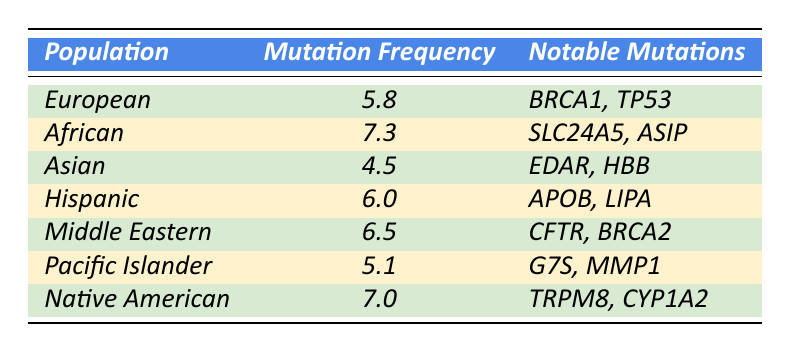What is the mutation frequency for the African population? The table shows that the mutation frequency for the African population is listed directly under the "Mutation Frequency" column as 7.3.
Answer: 7.3 Which population has the lowest mutation frequency? In the table, by comparing the "Mutation Frequency" values, the Asian population has the lowest mutation frequency at 4.5.
Answer: Asian What are the notable mutations for the Hispanic population? The table under the "Notable Mutations" column lists "APOB, LIPA" for the Hispanic population, which can be directly retrieved from the table.
Answer: APOB, LIPA How many populations have a mutation frequency greater than 6.0? By examining the table, the populations with mutation frequencies greater than 6.0 are African (7.3), Hispanic (6.0), Middle Eastern (6.5), and Native American (7.0). Thus, there are four populations.
Answer: 4 What is the average mutation frequency across all listed populations? To find the average, add the mutation frequencies: (5.8 + 7.3 + 4.5 + 6.0 + 6.5 + 5.1 + 7.0) = 42.2. There are 7 populations, so the average is 42.2 / 7 = 6.03.
Answer: 6.03 Is the mutation frequency for the Pacific Islander population higher than 6.0? The table shows that the mutation frequency for Pacific Islanders is 5.1, which is less than 6.0, thus the statement is false.
Answer: No Which population has the highest mutation frequency, and what is that frequency? From the table, the African population has the highest mutation frequency at 7.3, as confirmed by scanning the frequency values.
Answer: African, 7.3 If we grouped the populations by frequency ranges (below 5, 5 to 6, above 6), how many populations fall into the 'above 6' category? By analyzing the frequencies, we count African (7.3), Middle Eastern (6.5), and Native American (7.0) populations. This gives us a total of three populations in the 'above 6' range.
Answer: 3 